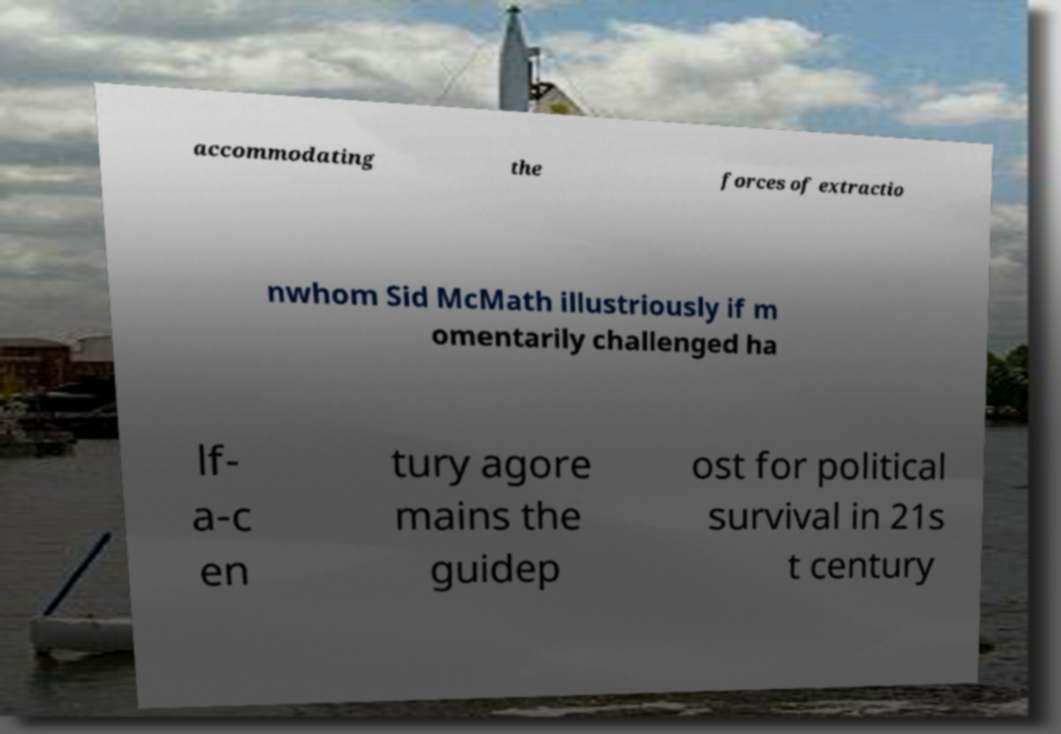I need the written content from this picture converted into text. Can you do that? accommodating the forces of extractio nwhom Sid McMath illustriously if m omentarily challenged ha lf- a-c en tury agore mains the guidep ost for political survival in 21s t century 